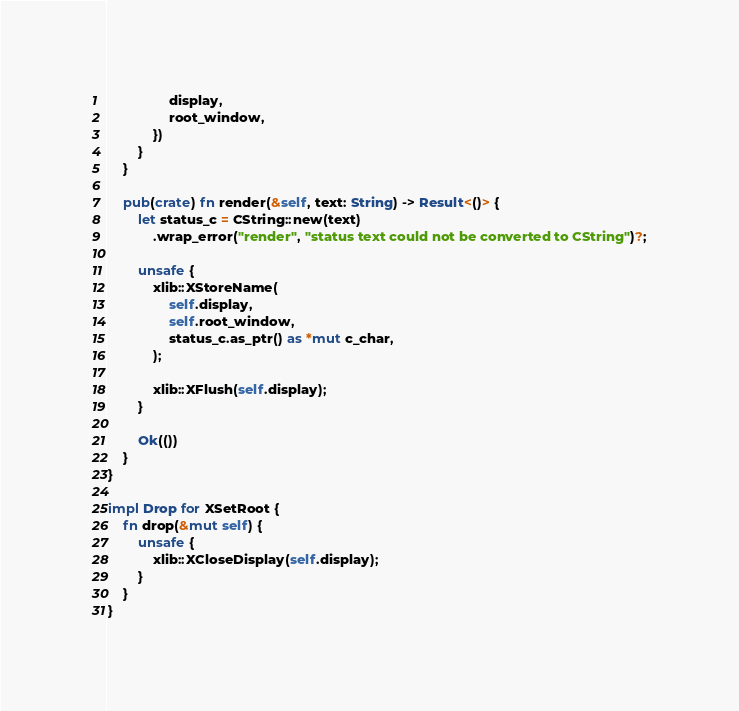Convert code to text. <code><loc_0><loc_0><loc_500><loc_500><_Rust_>                display,
                root_window,
            })
        }
    }

    pub(crate) fn render(&self, text: String) -> Result<()> {
        let status_c = CString::new(text)
            .wrap_error("render", "status text could not be converted to CString")?;

        unsafe {
            xlib::XStoreName(
                self.display,
                self.root_window,
                status_c.as_ptr() as *mut c_char,
            );

            xlib::XFlush(self.display);
        }

        Ok(())
    }
}

impl Drop for XSetRoot {
    fn drop(&mut self) {
        unsafe {
            xlib::XCloseDisplay(self.display);
        }
    }
}
</code> 